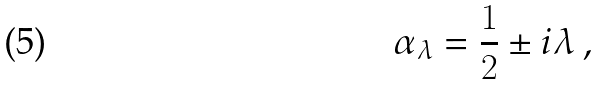Convert formula to latex. <formula><loc_0><loc_0><loc_500><loc_500>\alpha _ { \lambda } = \frac { 1 } { 2 } \pm i \lambda \, ,</formula> 